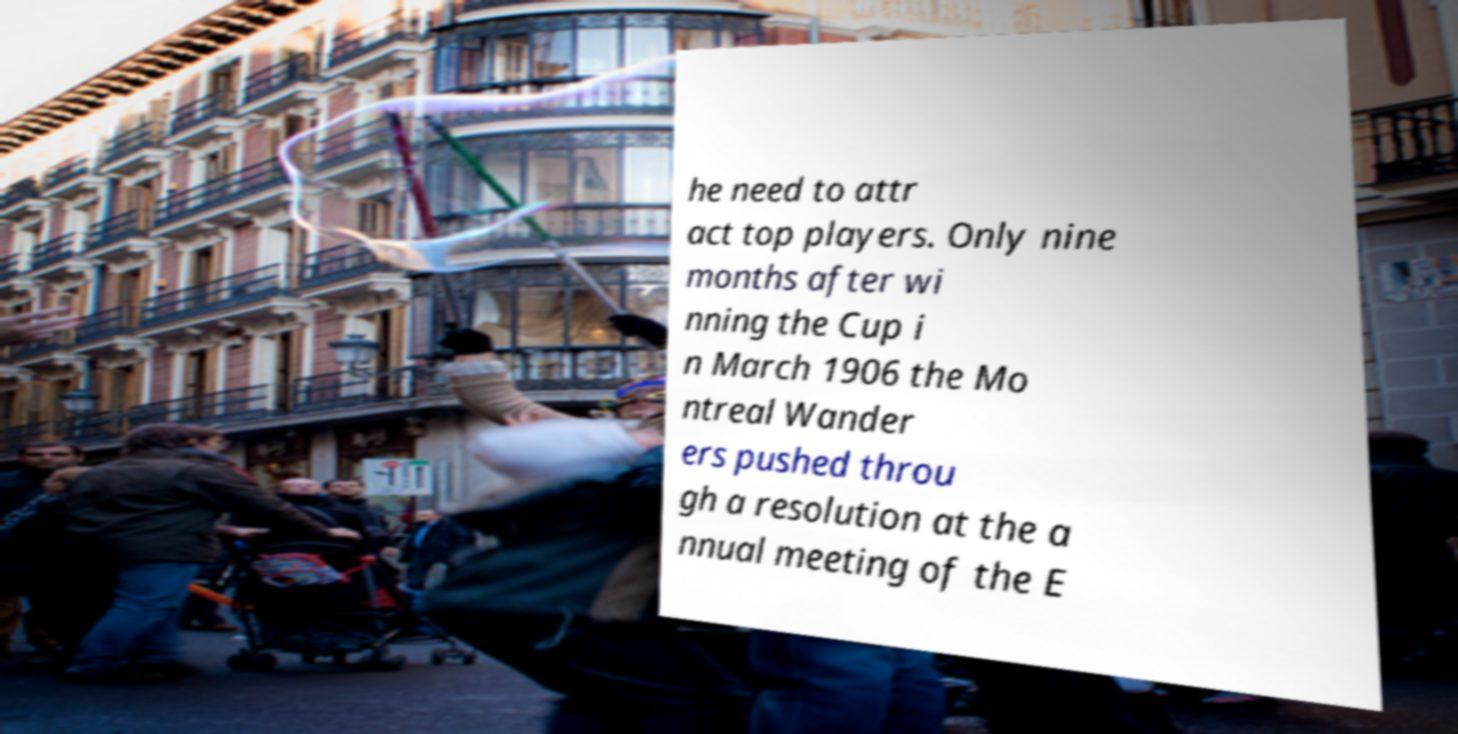Please identify and transcribe the text found in this image. he need to attr act top players. Only nine months after wi nning the Cup i n March 1906 the Mo ntreal Wander ers pushed throu gh a resolution at the a nnual meeting of the E 